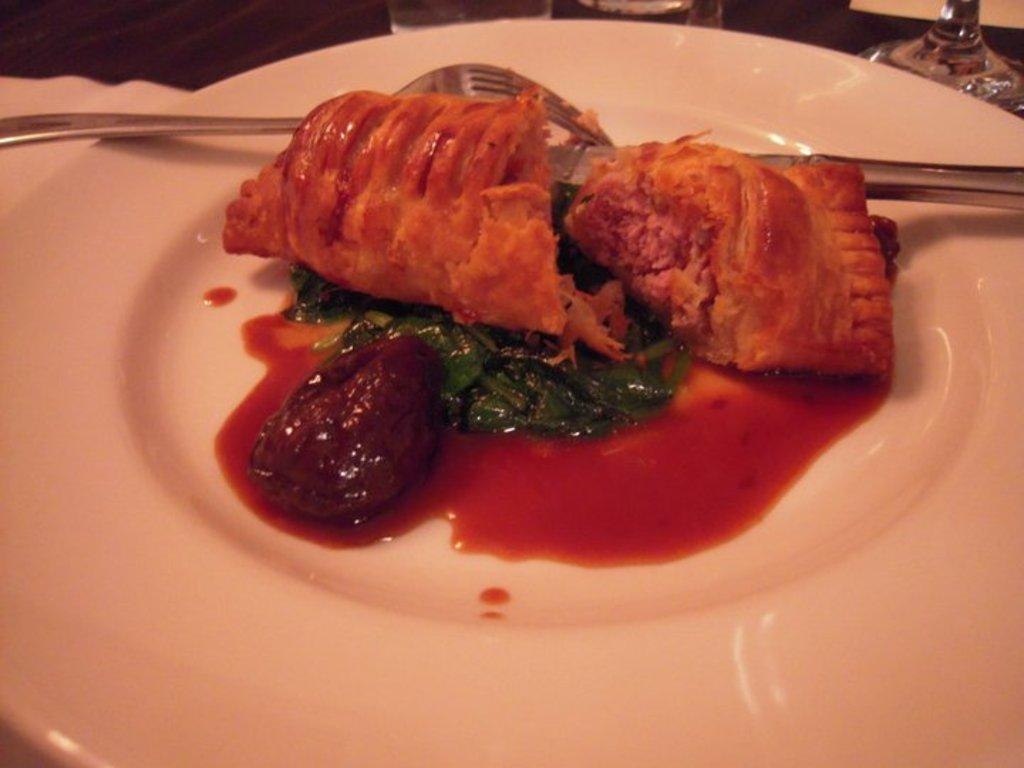What piece of furniture is present in the image? There is a table in the image. What is placed on the table? There is a plate on the table. What is on the plate? There is food on the plate. What utensils are on the table? There is a spoon and a knife on the table. What type of dishware is present on the table? There are glasses on the table. What type of popcorn is being used as a reward for the branch in the image? There is no popcorn, reward, or branch present in the image. 